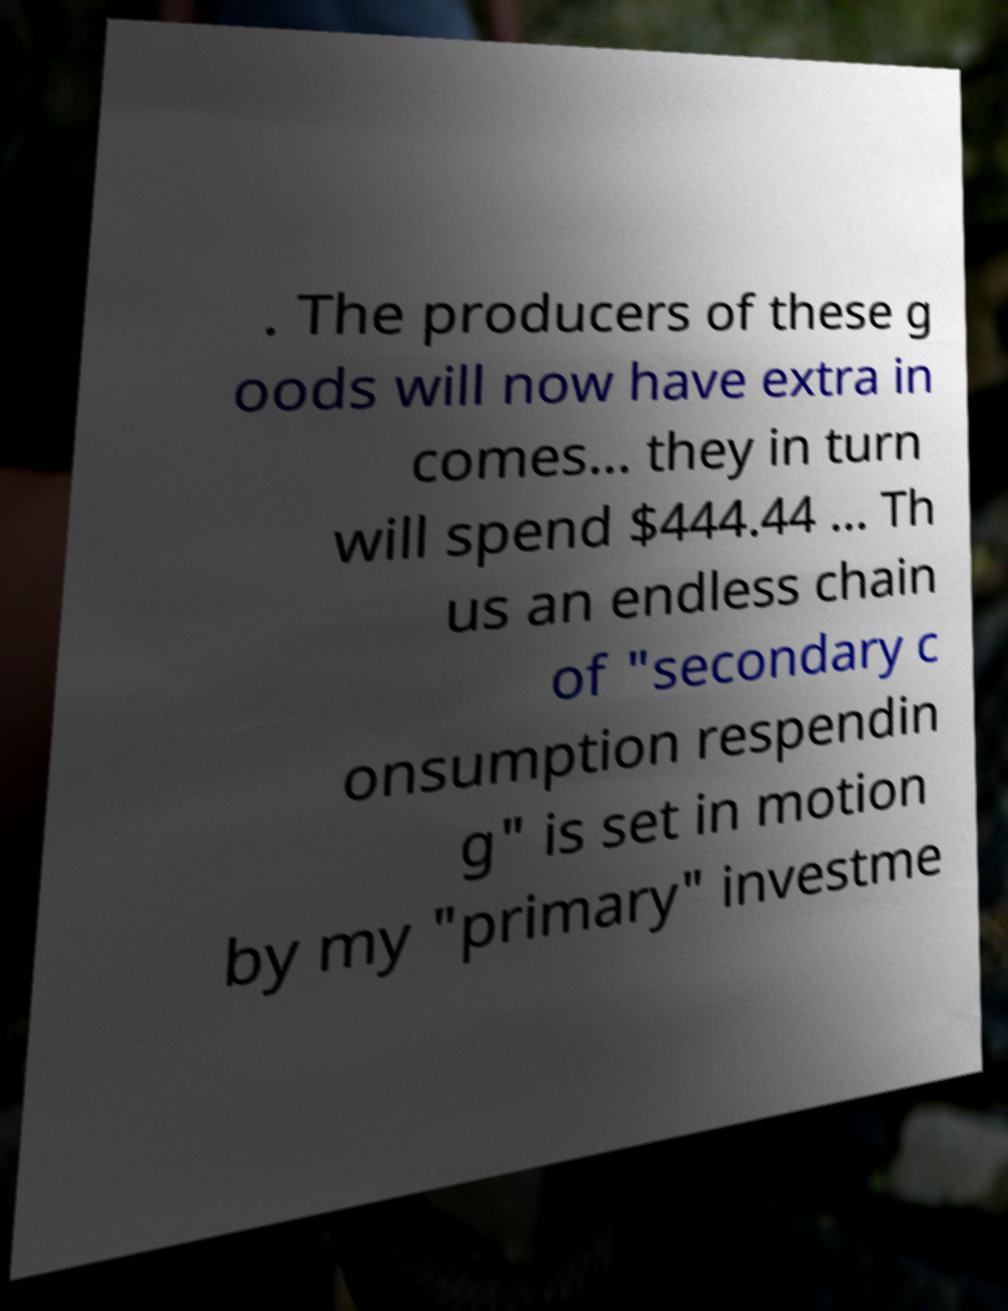Could you assist in decoding the text presented in this image and type it out clearly? . The producers of these g oods will now have extra in comes... they in turn will spend $444.44 ... Th us an endless chain of "secondary c onsumption respendin g" is set in motion by my "primary" investme 